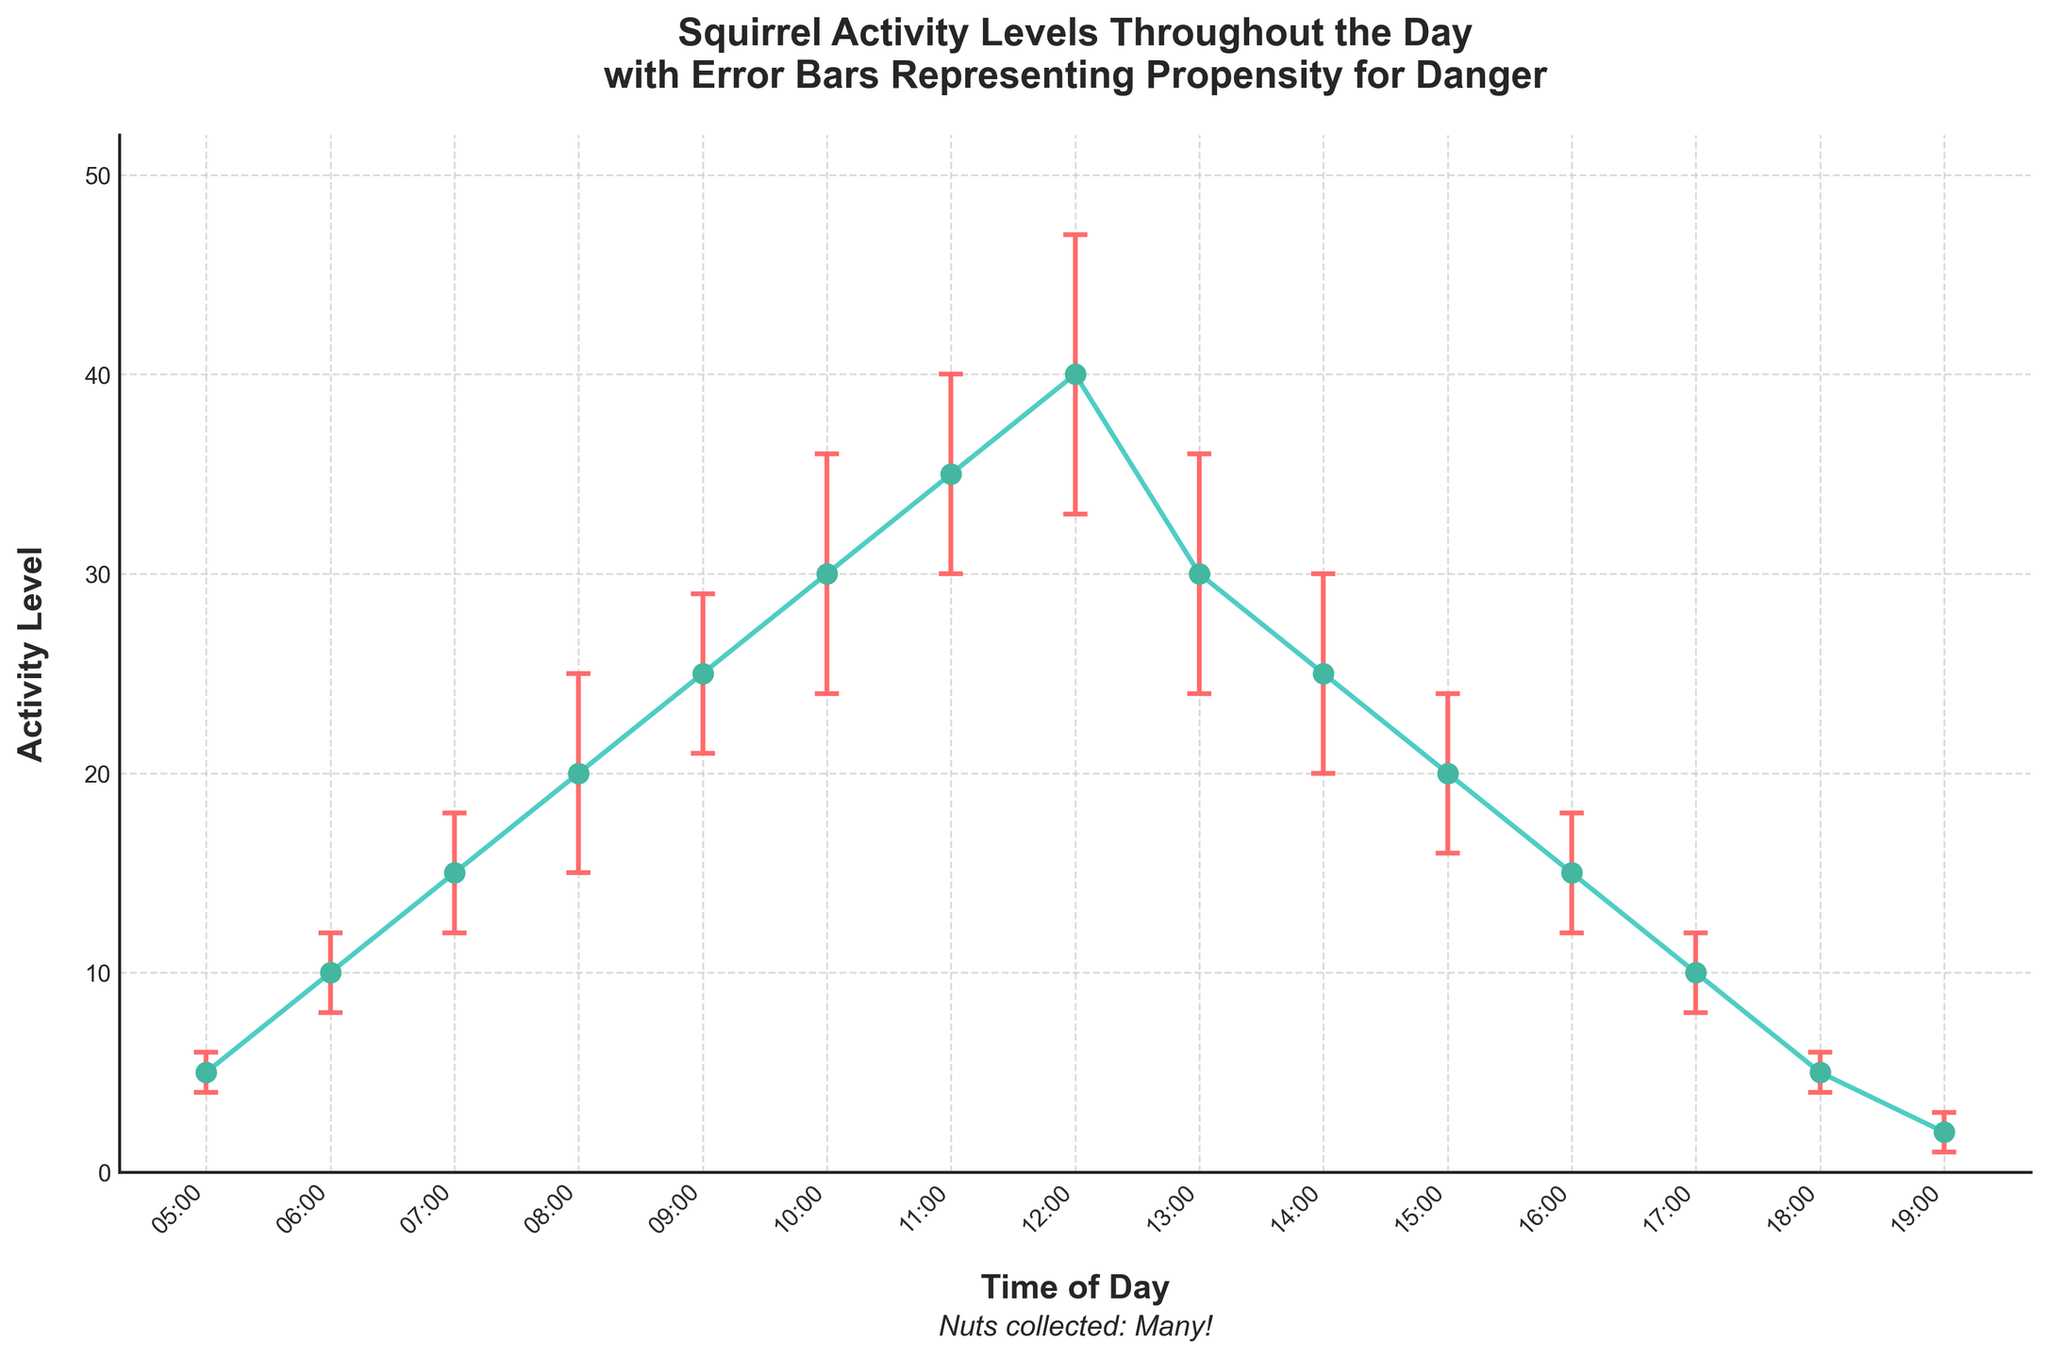What is the title of the figure? The title is located at the top of the figure, typically written in bold text that summarizes the main idea of the plot. The title of this figure is "Squirrel Activity Levels Throughout the Day with Error Bars Representing Propensity for Danger."
Answer: Squirrel Activity Levels Throughout the Day with Error Bars Representing Propensity for Danger At what times of the day are the activity levels the highest? From the plot, the peak(s) of the activity level curve indicate the highest levels. In this case, the activity level is highest at 12:00 with a value of 40.
Answer: 12:00 Compare the activity levels at 08:00 and 14:00. Which time has a higher activity level, and by how much? At 08:00, the activity level is 20. At 14:00, the activity level is 25. Comparing these, 14:00 has a higher activity level by 5 units.
Answer: 14:00, by 5 What is the error value at 10:00? The error bars represent the propensity for danger, and their length indicates the magnitude. The error value at 10:00 is shown directly on the plot as 6.
Answer: 6 During which hour does the activity level start to decrease after reaching its peak? The activity level peaks at 12:00 with a value of 40. After this time, it starts to decrease. Therefore, the activity level starts to drop after 12:00, beginning at 13:00.
Answer: 13:00 What is the average activity level between 05:00 and 07:00? The activity levels at 05:00, 06:00, and 07:00 are 5, 10, and 15 respectively. The average is calculated as (5 + 10 + 15) / 3 = 10.
Answer: 10 How do the propensity for danger error bars change from morning to evening? By visual inspection, the error bars (propensity for danger) generally increase as the activity levels increase in the morning and then decrease along with the activity levels in the evening. This shows a correlation between the activity levels and the propensity for danger.
Answer: Increase then decrease Which time period has the lowest activity level and what is the corresponding error value? The plot shows the lowest activity level at 19:00, with an activity level of 2. The corresponding error value, represented by the length of the error bar, is 1.
Answer: 19:00, error value 1 What is the total accumulation of activity levels from 10:00 to 14:00? The activity levels from 10:00 to 14:00 are 30, 35, 40, 30, and 25 respectively. Summing these up gives 30 + 35 + 40 + 30 + 25 = 160.
Answer: 160 Why might it be significant to note the error bars when considering activity levels? The error bars represent the propensity for danger, indicating variability or risk in the data. High error bars could suggest higher variability and risk, which is crucial for interpreting how safe it is for the squirrel and boar family to be active at those times.
Answer: Indicate variability and risk 